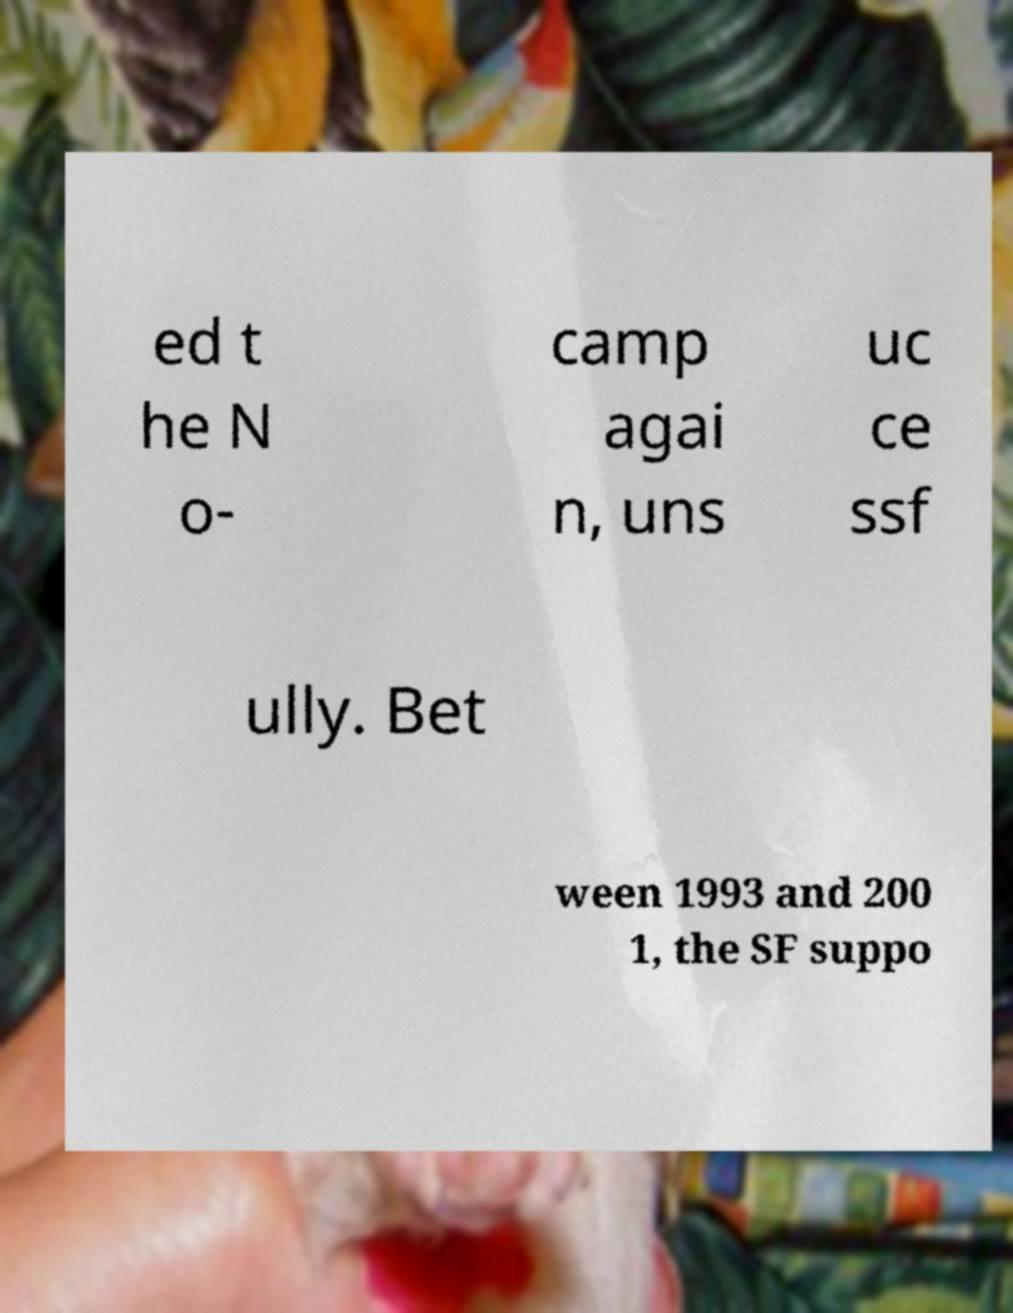Can you read and provide the text displayed in the image?This photo seems to have some interesting text. Can you extract and type it out for me? ed t he N o- camp agai n, uns uc ce ssf ully. Bet ween 1993 and 200 1, the SF suppo 